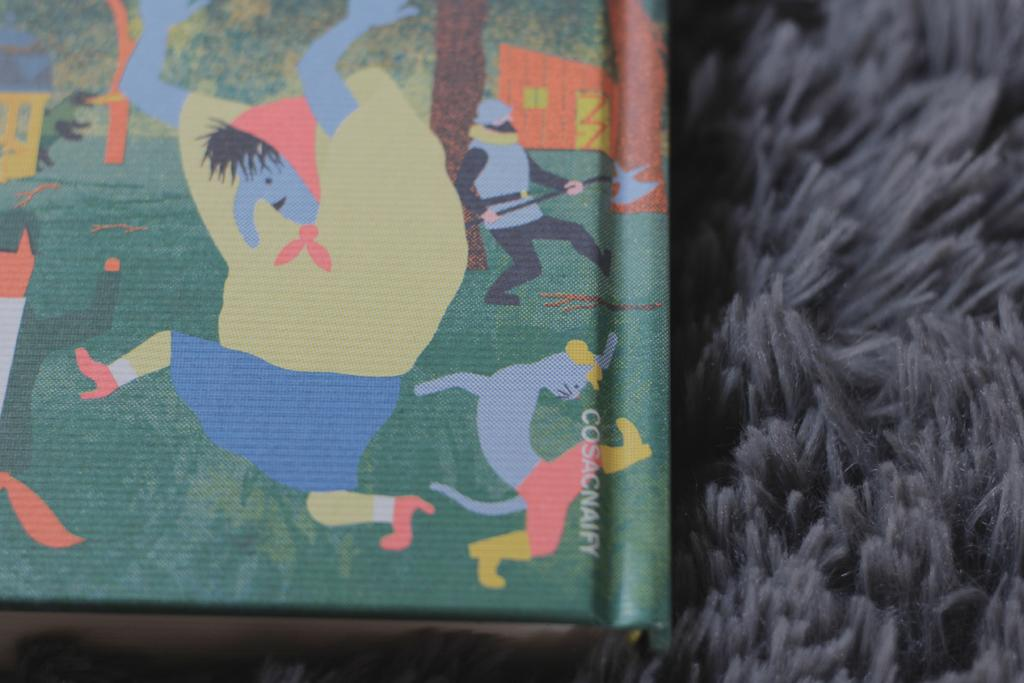What is placed on the mat in the image? There is a book placed on a mat. Can you describe the book's positioning on the mat? The book is placed directly on the mat. What type of operation is being performed on the book in the image? There is no operation being performed on the book in the image; it is simply placed on the mat. What country is depicted in the image? The image does not depict any specific country; it only shows a book placed on a mat. 